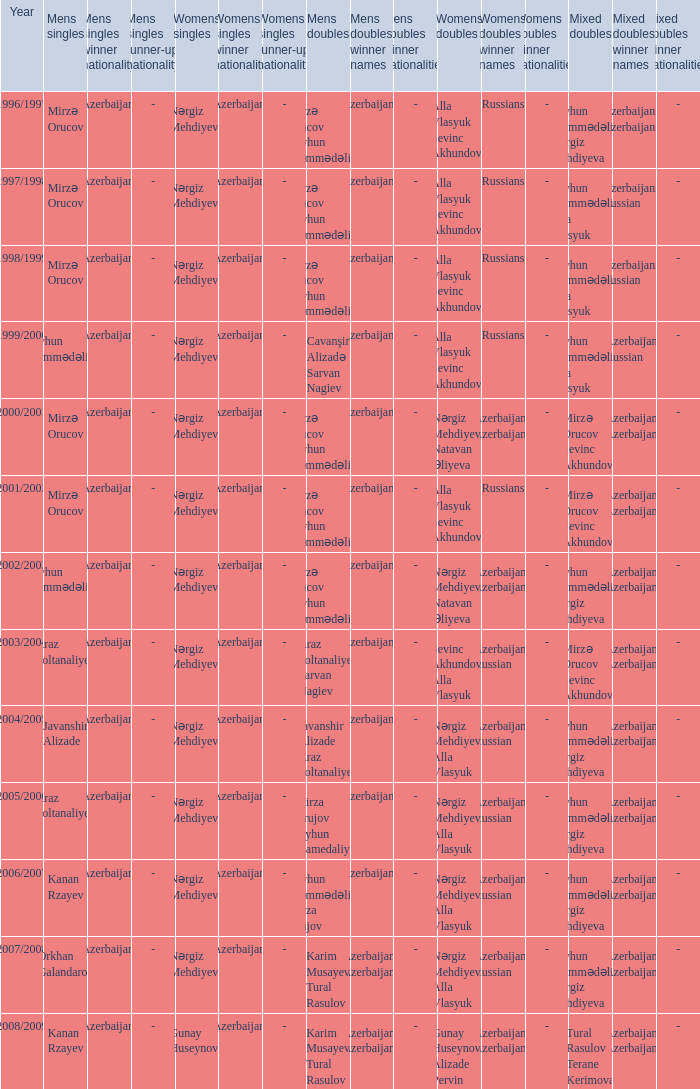What are all values for Womens Doubles in the year 2000/2001? Nərgiz Mehdiyeva Natavan Əliyeva. 